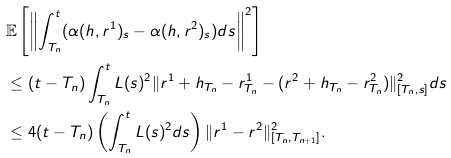Convert formula to latex. <formula><loc_0><loc_0><loc_500><loc_500>& \mathbb { E } \left [ \left \| \int _ { T _ { n } } ^ { t } ( \alpha ( h , r ^ { 1 } ) _ { s } - \alpha ( h , r ^ { 2 } ) _ { s } ) d s \right \| ^ { 2 } \right ] \\ & \leq ( t - T _ { n } ) \int _ { T _ { n } } ^ { t } L ( s ) ^ { 2 } \| r ^ { 1 } + h _ { T _ { n } } - r _ { T _ { n } } ^ { 1 } - ( r ^ { 2 } + h _ { T _ { n } } - r _ { T _ { n } } ^ { 2 } ) \| _ { [ T _ { n } , s ] } ^ { 2 } d s \\ & \leq 4 ( t - T _ { n } ) \left ( \int _ { T _ { n } } ^ { t } L ( s ) ^ { 2 } d s \right ) \| r ^ { 1 } - r ^ { 2 } \| _ { [ T _ { n } , T _ { n + 1 } ] } ^ { 2 } .</formula> 